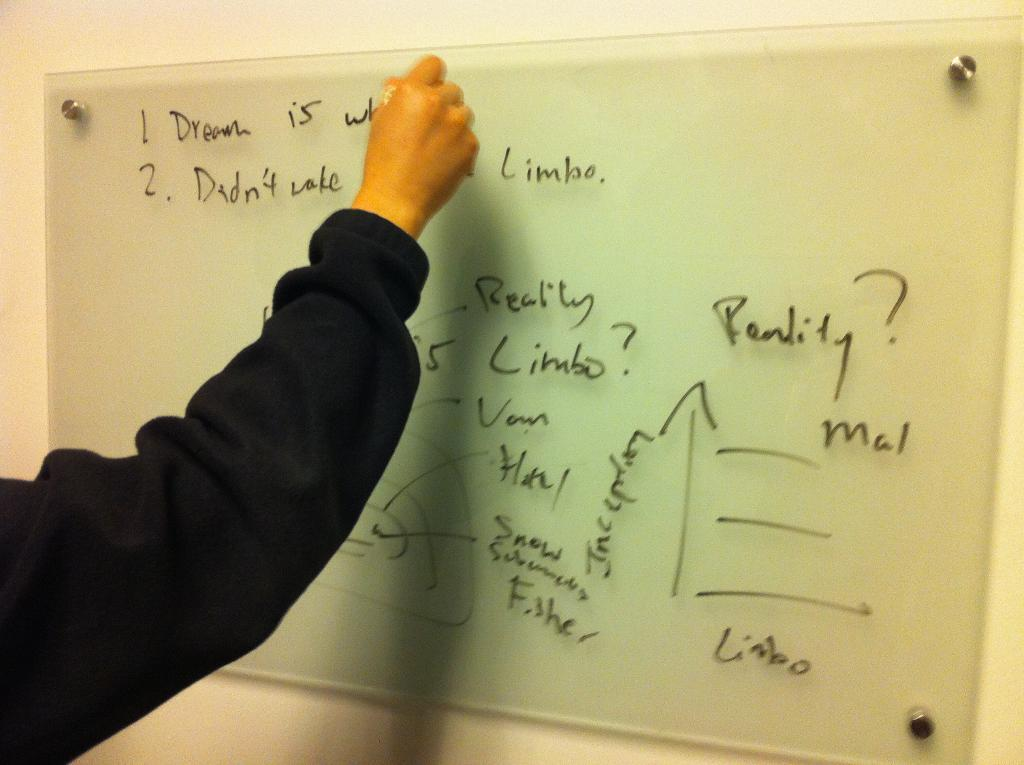<image>
Provide a brief description of the given image. A man writes Dream is something on a whiteboard. 